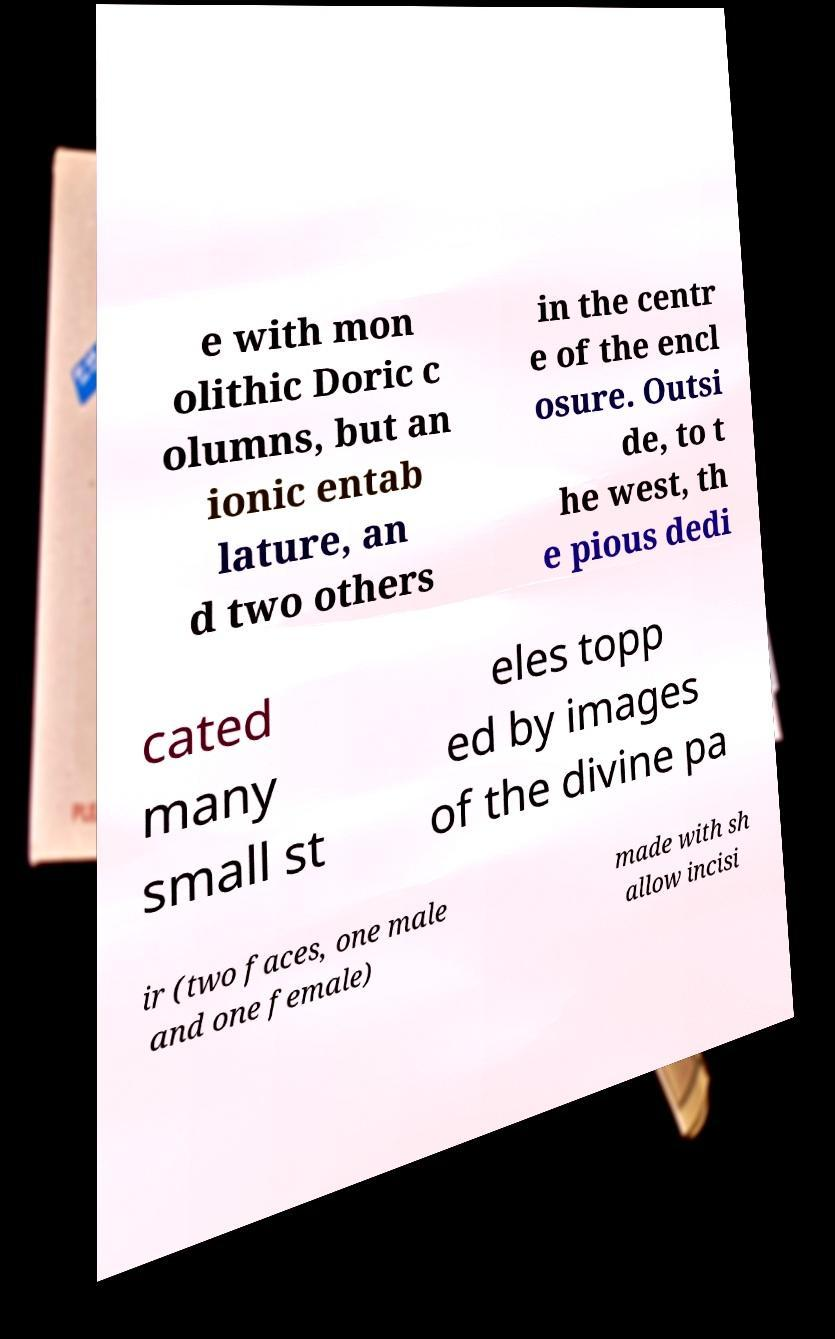I need the written content from this picture converted into text. Can you do that? e with mon olithic Doric c olumns, but an ionic entab lature, an d two others in the centr e of the encl osure. Outsi de, to t he west, th e pious dedi cated many small st eles topp ed by images of the divine pa ir (two faces, one male and one female) made with sh allow incisi 